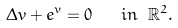Convert formula to latex. <formula><loc_0><loc_0><loc_500><loc_500>\Delta v + e ^ { v } = 0 \quad i n \ \mathbb { R } ^ { 2 } .</formula> 